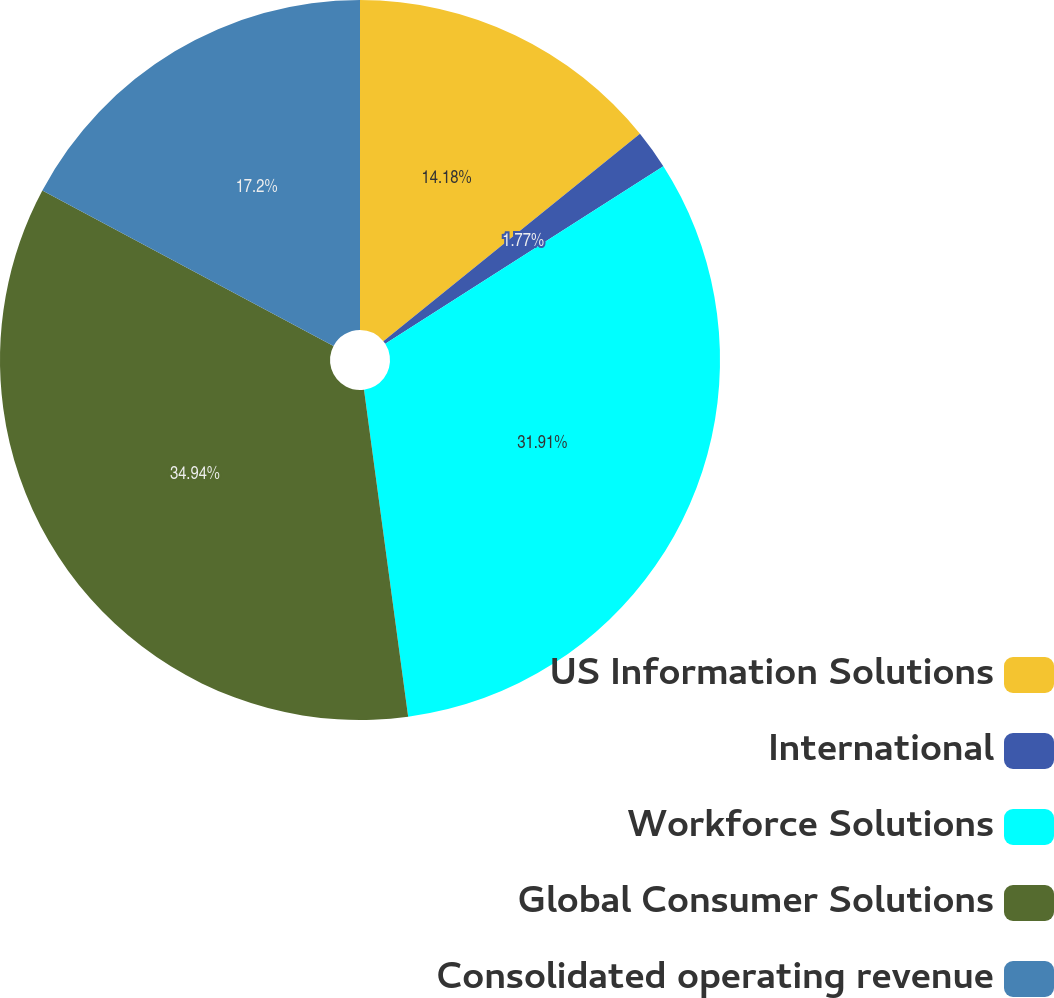Convert chart to OTSL. <chart><loc_0><loc_0><loc_500><loc_500><pie_chart><fcel>US Information Solutions<fcel>International<fcel>Workforce Solutions<fcel>Global Consumer Solutions<fcel>Consolidated operating revenue<nl><fcel>14.18%<fcel>1.77%<fcel>31.91%<fcel>34.93%<fcel>17.2%<nl></chart> 